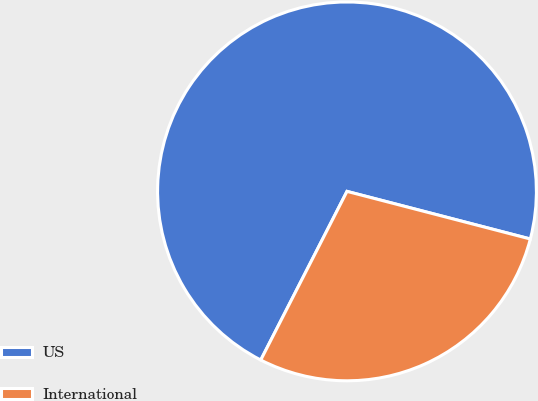<chart> <loc_0><loc_0><loc_500><loc_500><pie_chart><fcel>US<fcel>International<nl><fcel>71.52%<fcel>28.48%<nl></chart> 